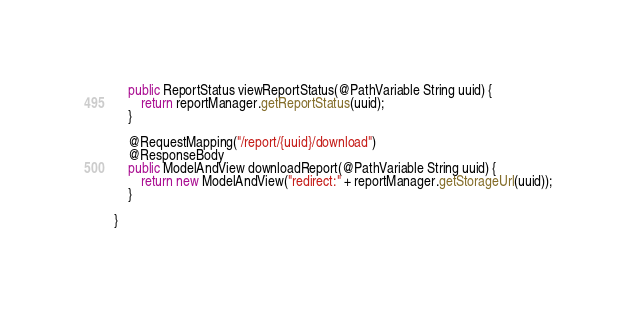<code> <loc_0><loc_0><loc_500><loc_500><_Java_>    public ReportStatus viewReportStatus(@PathVariable String uuid) {
        return reportManager.getReportStatus(uuid);
    }

    @RequestMapping("/report/{uuid}/download")
    @ResponseBody
    public ModelAndView downloadReport(@PathVariable String uuid) {
        return new ModelAndView("redirect:" + reportManager.getStorageUrl(uuid));
    }

}
</code> 